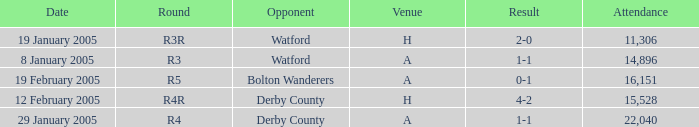What is the round of the game at venue H and opponent of Derby County? R4R. 